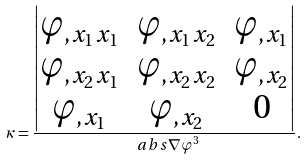Convert formula to latex. <formula><loc_0><loc_0><loc_500><loc_500>\kappa = \frac { \begin{vmatrix} \varphi _ { , x _ { 1 } x _ { 1 } } & \varphi _ { , x _ { 1 } x _ { 2 } } & \varphi _ { , x _ { 1 } } \\ \varphi _ { , x _ { 2 } x _ { 1 } } & \varphi _ { , x _ { 2 } x _ { 2 } } & \varphi _ { , x _ { 2 } } \\ \varphi _ { , x _ { 1 } } & \varphi _ { , x _ { 2 } } & 0 \end{vmatrix} } { \ a b s { \nabla \varphi } ^ { 3 } } .</formula> 